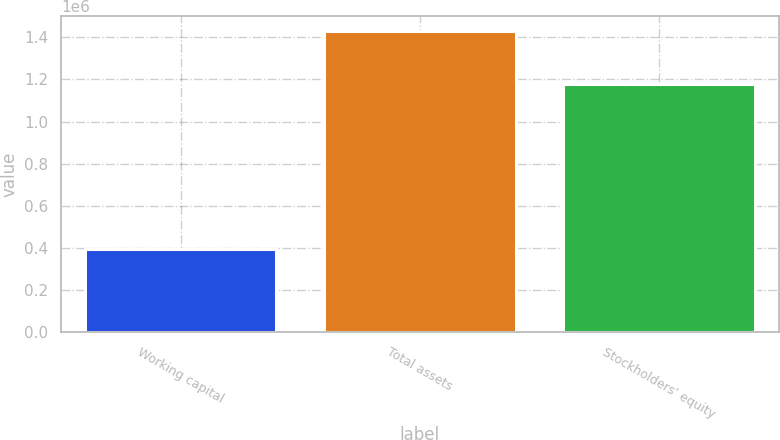Convert chart to OTSL. <chart><loc_0><loc_0><loc_500><loc_500><bar_chart><fcel>Working capital<fcel>Total assets<fcel>Stockholders' equity<nl><fcel>393979<fcel>1.42828e+06<fcel>1.17895e+06<nl></chart> 